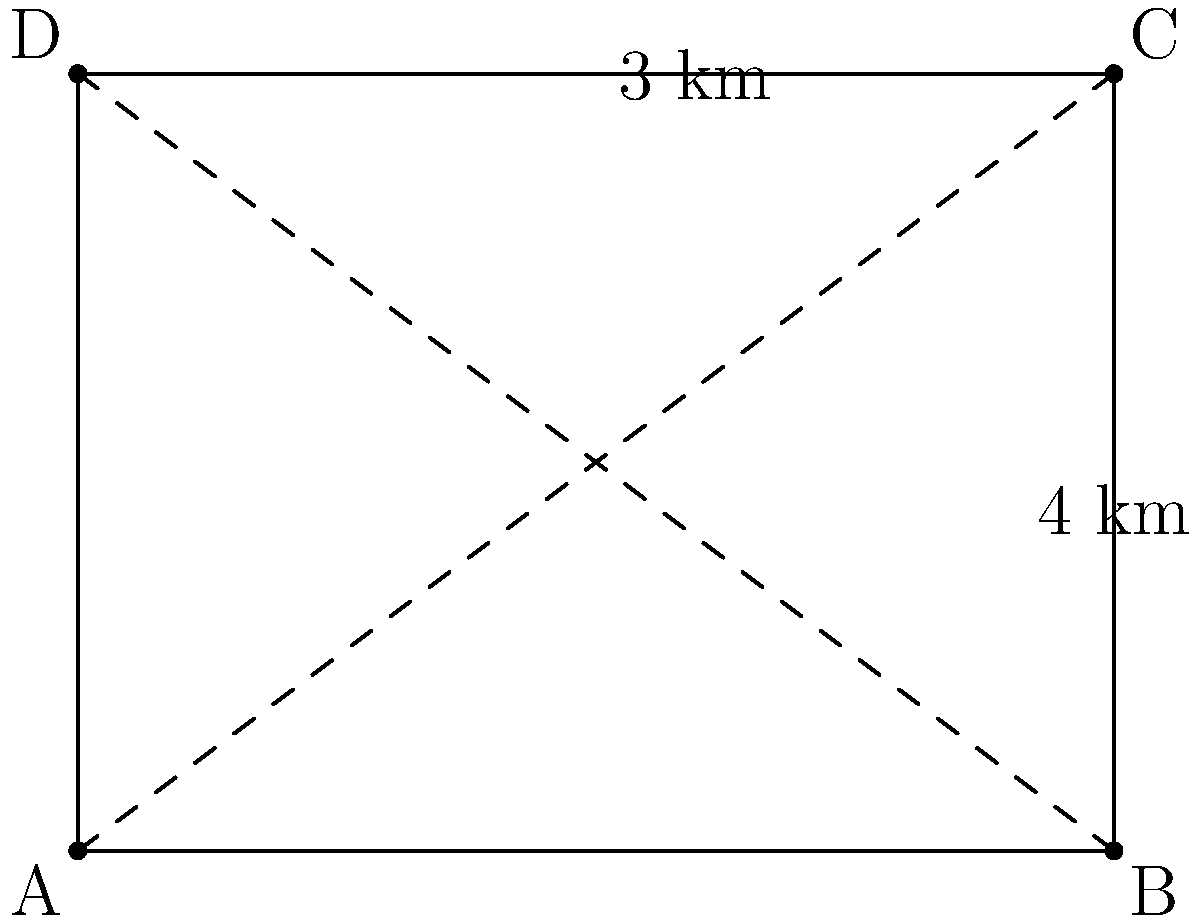During a neighborhood recycling drive, volunteers need to cover a rectangular area as shown in the diagram. If they start at point A and need to visit all corners (B, C, and D) before returning to A, what is the shortest possible route in kilometers? To find the shortest route, we need to consider the possible paths and use the properties of right triangles:

1. The rectangle's dimensions are 4 km by 3 km.

2. The diagonal AC can be calculated using the Pythagorean theorem:
   $$AC = \sqrt{4^2 + 3^2} = \sqrt{16 + 9} = \sqrt{25} = 5$$ km

3. Possible routes:
   a) A → B → C → D → A: 4 + 3 + 4 + 3 = 14 km
   b) A → D → C → B → A: 3 + 4 + 3 + 4 = 14 km
   c) A → C → B → D → A: 5 + 4 + 3 = 12 km
   d) A → C → D → B → A: 5 + 3 + 4 = 12 km

4. The shortest routes are c and d, both covering 12 km.

Therefore, the shortest possible route is 12 km, which can be achieved by crossing the diagonal once and then following the perimeter.
Answer: 12 km 